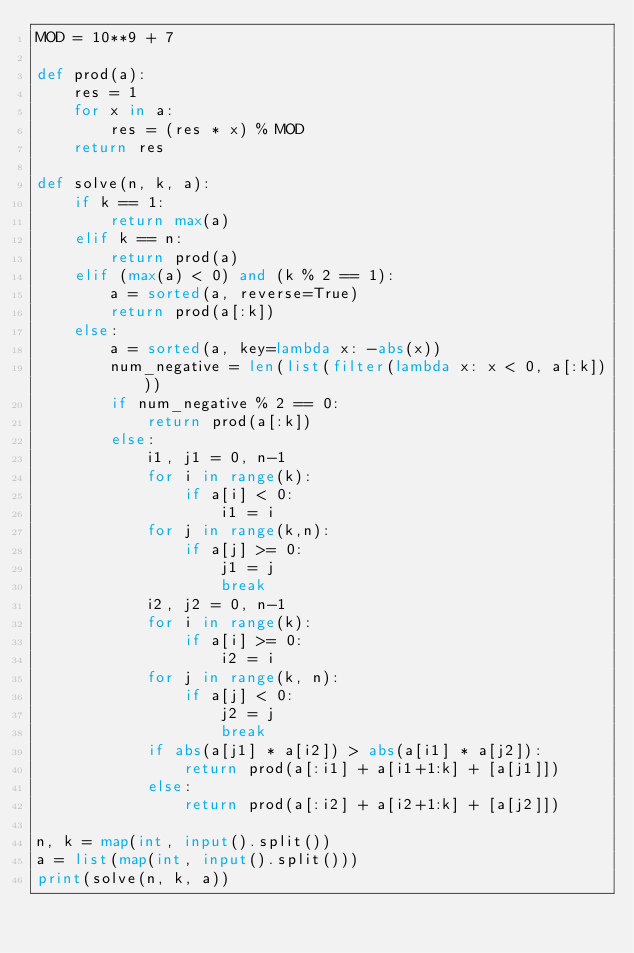<code> <loc_0><loc_0><loc_500><loc_500><_Python_>MOD = 10**9 + 7

def prod(a):
    res = 1
    for x in a:
        res = (res * x) % MOD
    return res

def solve(n, k, a):
    if k == 1:
        return max(a)
    elif k == n:
        return prod(a)
    elif (max(a) < 0) and (k % 2 == 1):
        a = sorted(a, reverse=True)
        return prod(a[:k])
    else:
        a = sorted(a, key=lambda x: -abs(x))
        num_negative = len(list(filter(lambda x: x < 0, a[:k])))
        if num_negative % 2 == 0:
            return prod(a[:k])
        else:
            i1, j1 = 0, n-1
            for i in range(k):
                if a[i] < 0:
                    i1 = i
            for j in range(k,n):
                if a[j] >= 0:
                    j1 = j
                    break
            i2, j2 = 0, n-1
            for i in range(k):
                if a[i] >= 0:
                    i2 = i
            for j in range(k, n):
                if a[j] < 0:
                    j2 = j
                    break
            if abs(a[j1] * a[i2]) > abs(a[i1] * a[j2]):
                return prod(a[:i1] + a[i1+1:k] + [a[j1]])
            else:
                return prod(a[:i2] + a[i2+1:k] + [a[j2]])

n, k = map(int, input().split())
a = list(map(int, input().split()))
print(solve(n, k, a))</code> 